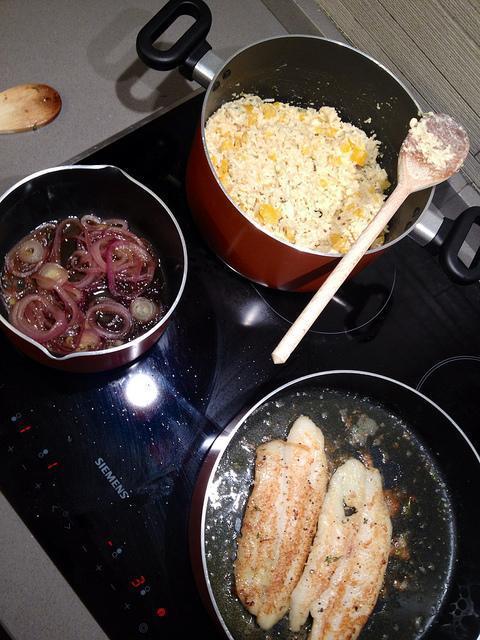How many wooden spoons do you see?
Give a very brief answer. 2. How many pots are on the stove?
Give a very brief answer. 3. How many bowls are visible?
Give a very brief answer. 2. 